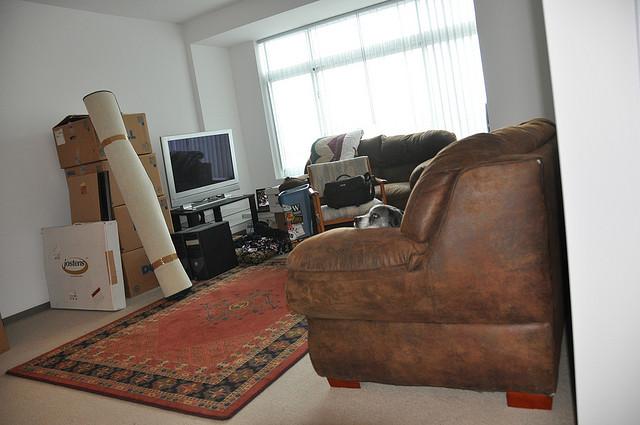Is there anyone in this apartment?
Concise answer only. No. Are both carpets spread out?
Short answer required. No. What color is the couch?
Keep it brief. Brown. What color is the chair?
Give a very brief answer. Brown. 